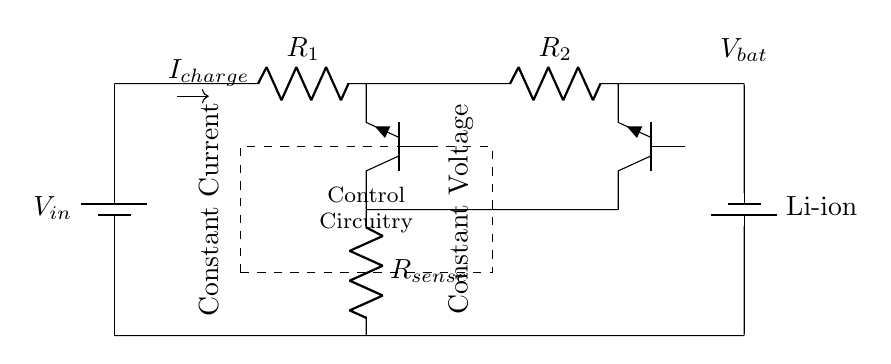What type of battery is used in this circuit? The circuit diagram indicates that a lithium-ion battery is used, as labeled next to the battery symbol.
Answer: lithium-ion What are the two charging phases indicated in the diagram? The diagram shows two distinct phases for charging: constant current and constant voltage, which are noted in labeled sections of the circuit.
Answer: constant current and constant voltage What is the purpose of the sense resistor in this circuit? The sense resistor is used to monitor the current flowing into the battery. By measuring the voltage drop across it, the control circuitry can regulate the charging current accurately.
Answer: monitor charging current Which component acts as a switch in the constant current stage? The transistor labeled Q1 functions as a switch that controls the flow of current during the constant current phase, regulating it to the desired level.
Answer: Q1 How is the transition between charging phases controlled? The transition from the constant current phase to the constant voltage phase is managed by control circuitry that monitors the battery voltage and adjusts the operation of the transistors accordingly.
Answer: control circuitry What does the arrow labeled with the current direction represent? The arrow indicates the direction of the charging current flowing into the battery, showing how current is supplied during the charging process.
Answer: I charge 